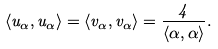Convert formula to latex. <formula><loc_0><loc_0><loc_500><loc_500>\langle u _ { \alpha } , u _ { \alpha } \rangle = \langle v _ { \alpha } , v _ { \alpha } \rangle = \frac { 4 } { \langle \alpha , \alpha \rangle } .</formula> 